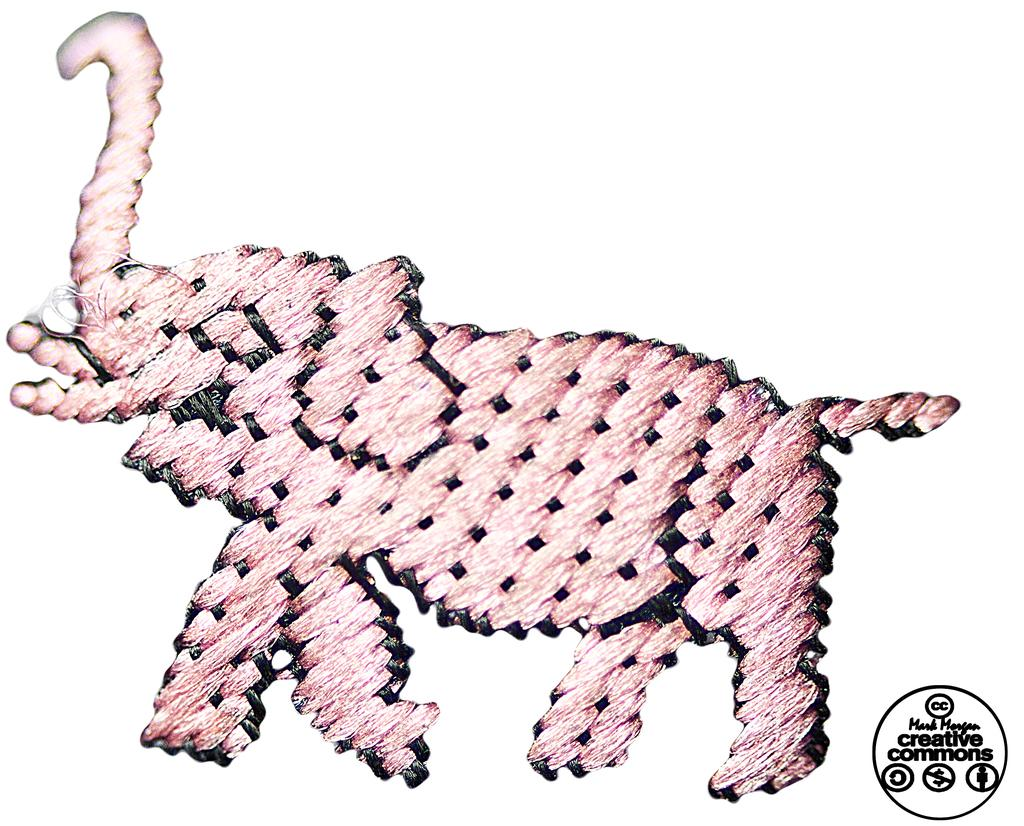What is the main subject of the painting in the image? The main subject of the painting in the image is an elephant. Where is the painting located in the image? The painting is in the center of the image. What else can be seen in the bottom right corner of the image? There is text and logos in the bottom right corner of the image. What type of vest is the elephant wearing in the image? There is no vest present on the elephant in the image, as it is a painting of an elephant and not a photograph of a real elephant. 